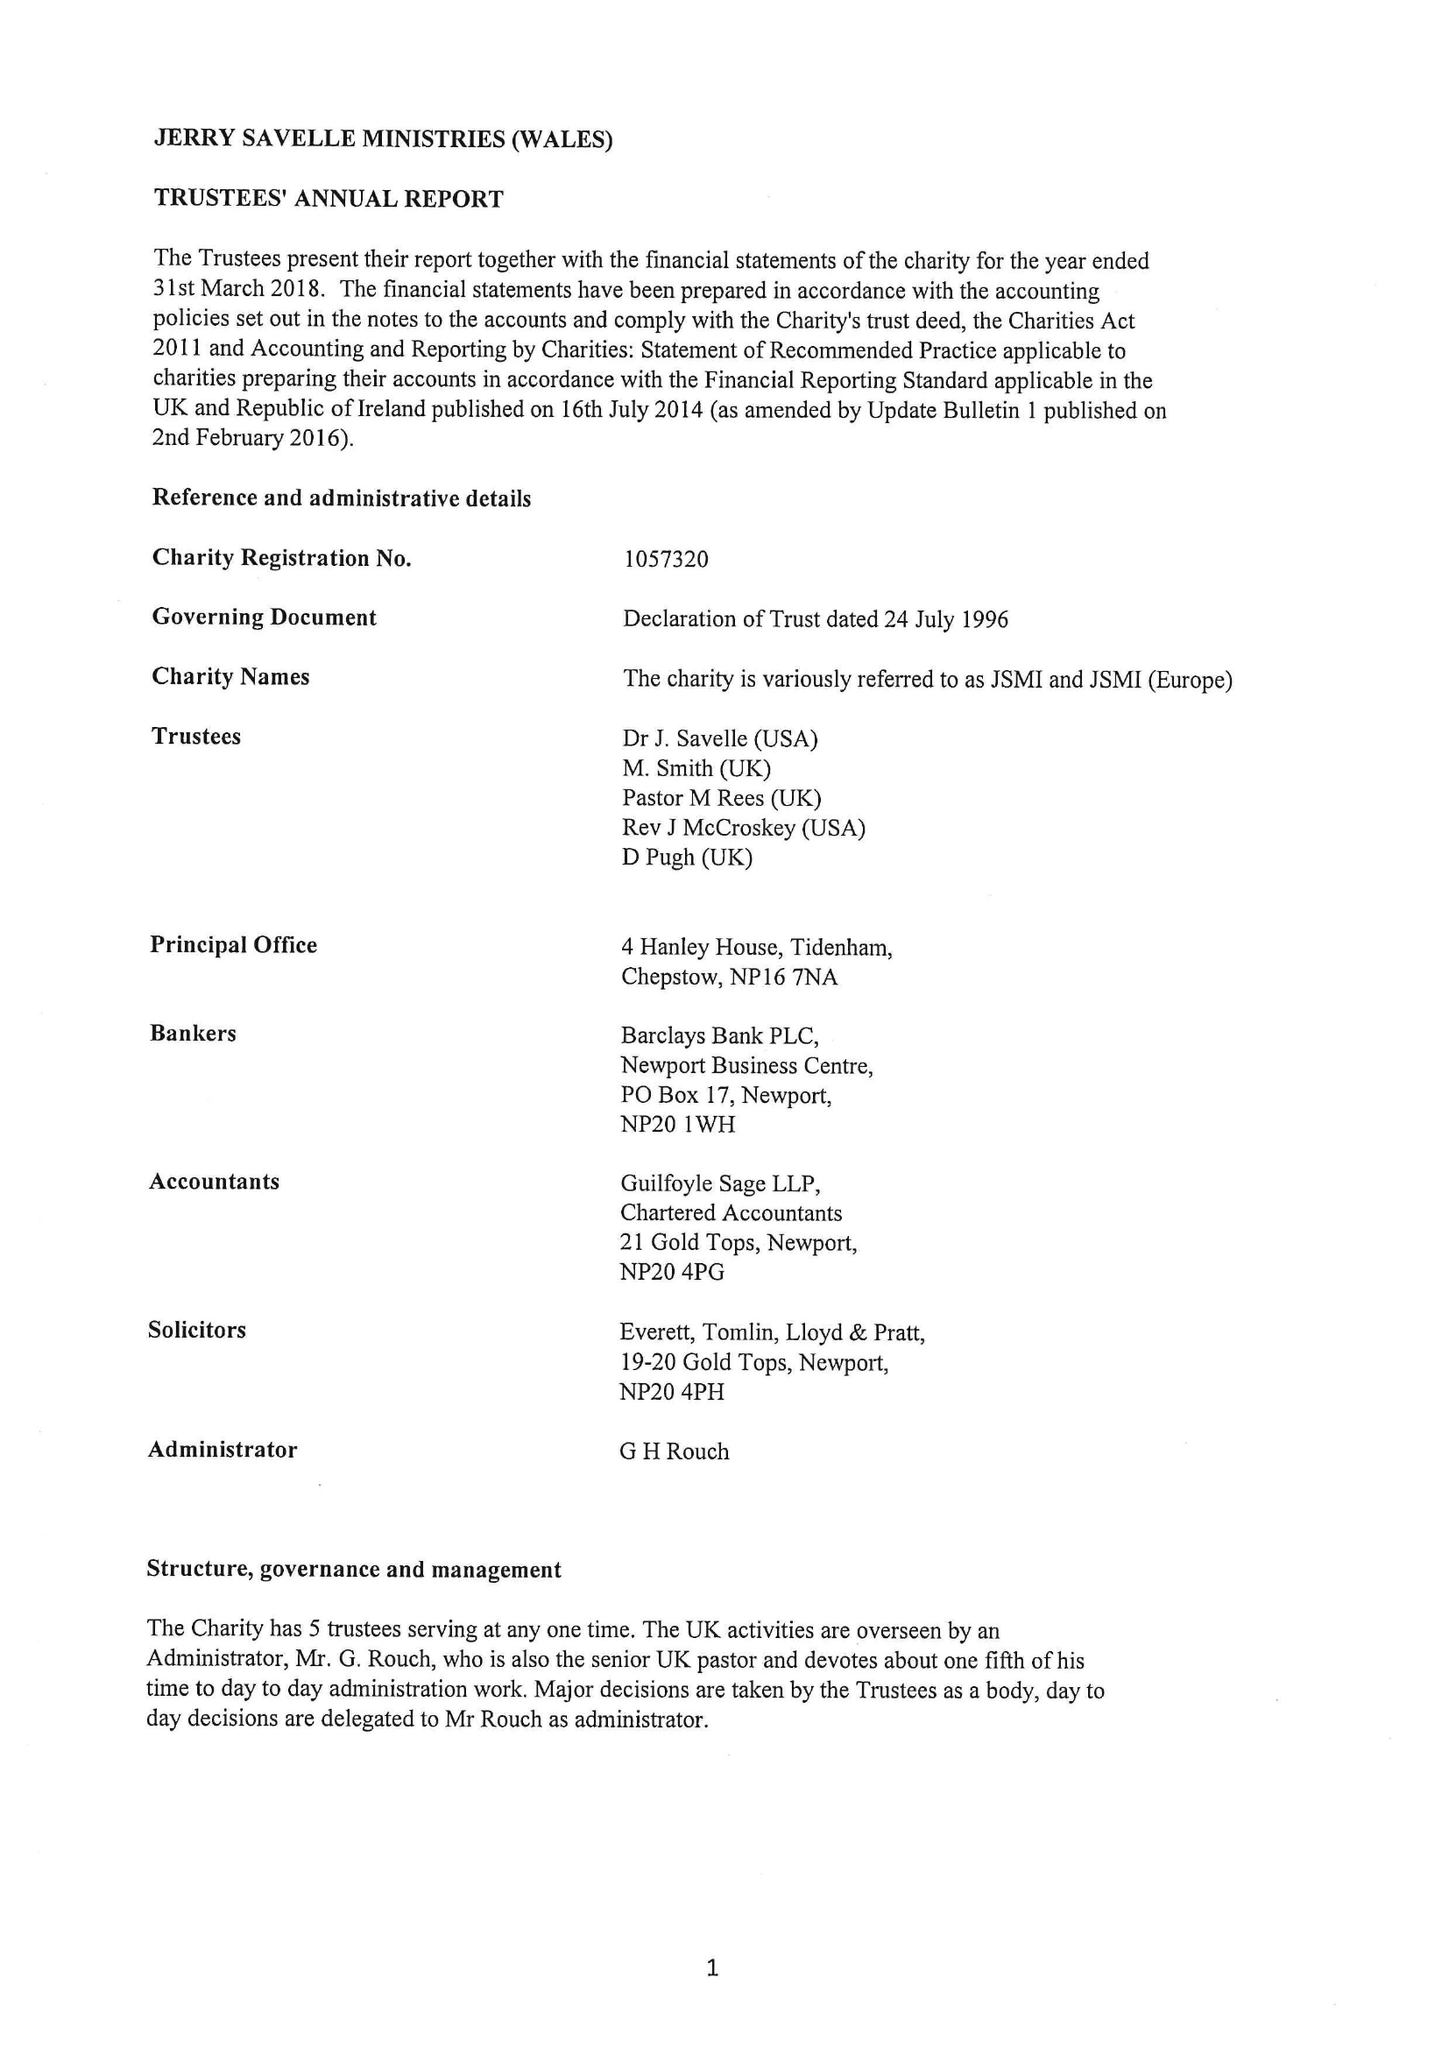What is the value for the charity_number?
Answer the question using a single word or phrase. 1057320 